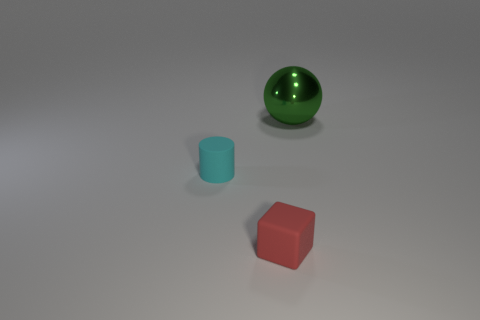Add 2 tiny cyan spheres. How many objects exist? 5 Subtract all cylinders. How many objects are left? 2 Subtract 0 purple cylinders. How many objects are left? 3 Subtract all small yellow shiny things. Subtract all cyan rubber cylinders. How many objects are left? 2 Add 2 cyan rubber things. How many cyan rubber things are left? 3 Add 1 big green balls. How many big green balls exist? 2 